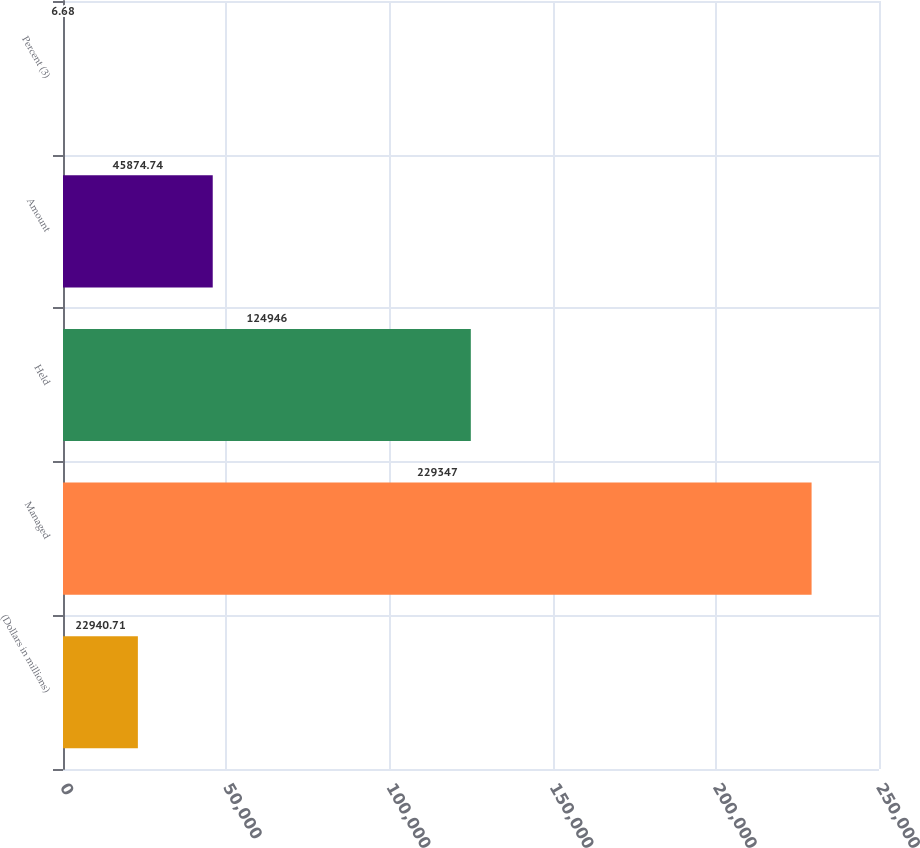Convert chart to OTSL. <chart><loc_0><loc_0><loc_500><loc_500><bar_chart><fcel>(Dollars in millions)<fcel>Managed<fcel>Held<fcel>Amount<fcel>Percent (3)<nl><fcel>22940.7<fcel>229347<fcel>124946<fcel>45874.7<fcel>6.68<nl></chart> 